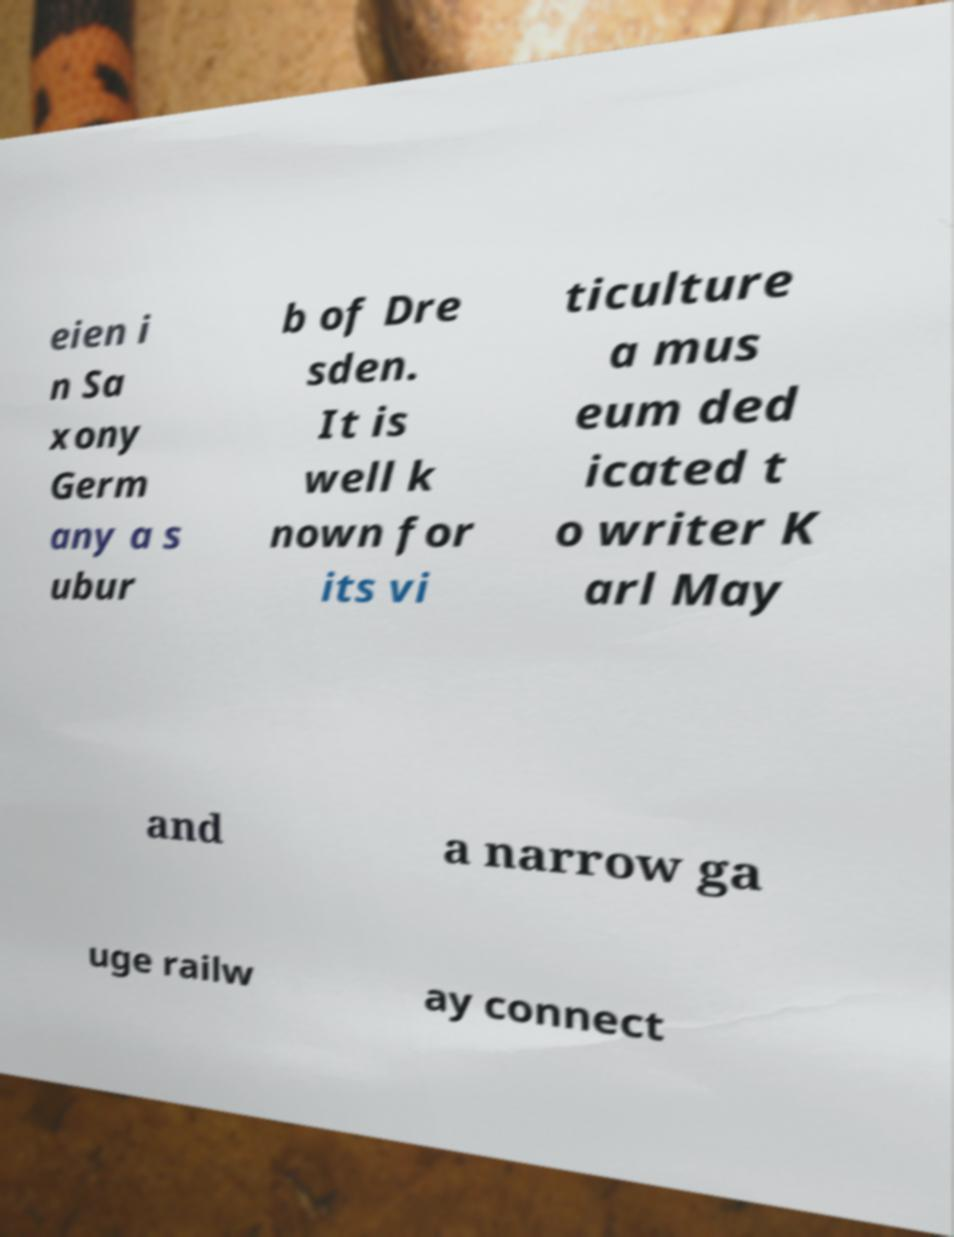Please read and relay the text visible in this image. What does it say? eien i n Sa xony Germ any a s ubur b of Dre sden. It is well k nown for its vi ticulture a mus eum ded icated t o writer K arl May and a narrow ga uge railw ay connect 